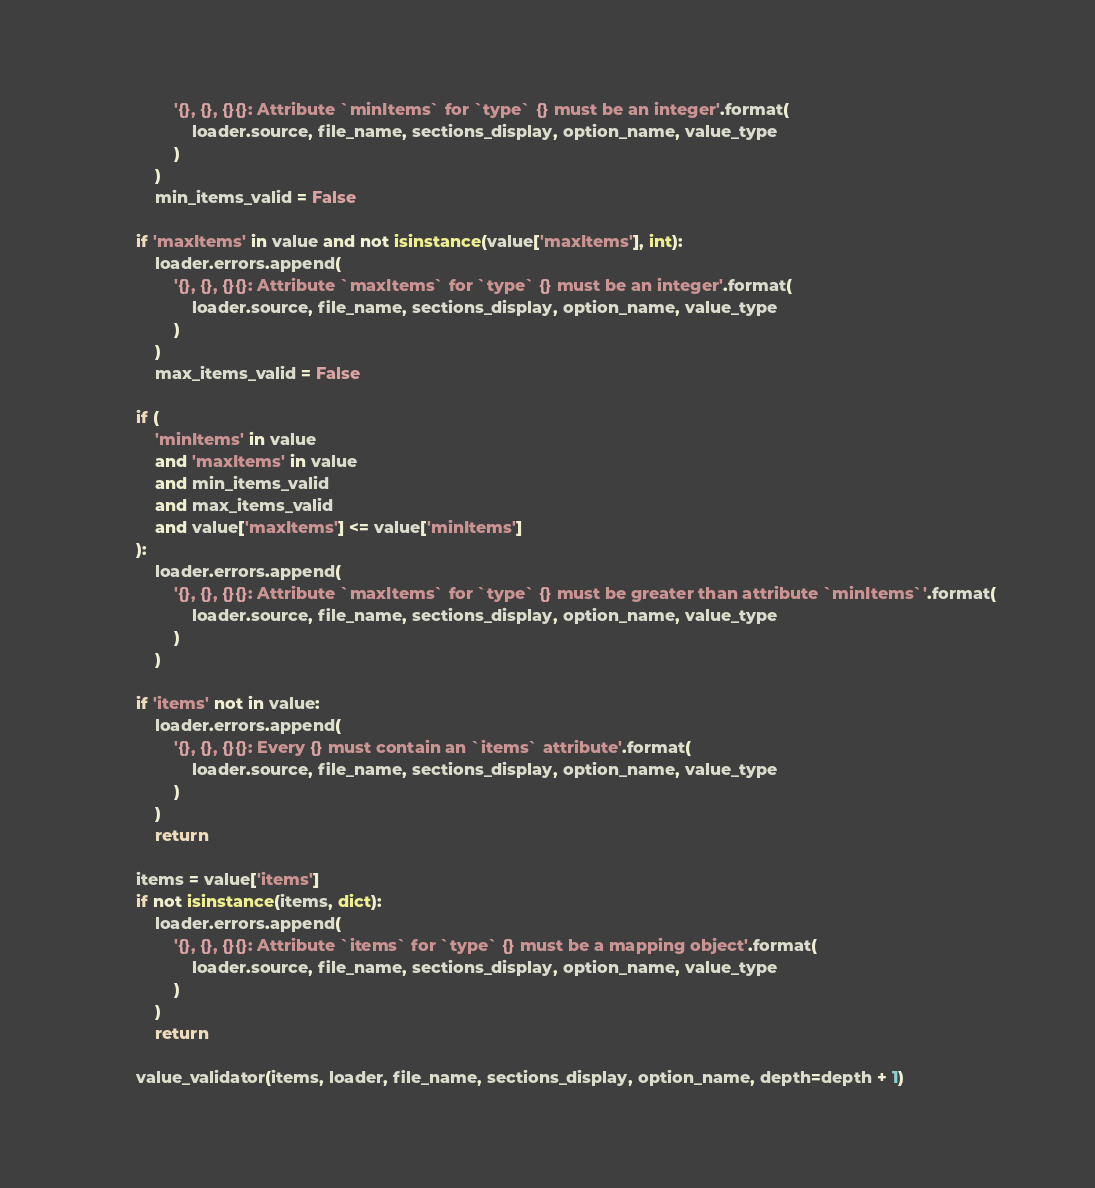Convert code to text. <code><loc_0><loc_0><loc_500><loc_500><_Python_>                '{}, {}, {}{}: Attribute `minItems` for `type` {} must be an integer'.format(
                    loader.source, file_name, sections_display, option_name, value_type
                )
            )
            min_items_valid = False

        if 'maxItems' in value and not isinstance(value['maxItems'], int):
            loader.errors.append(
                '{}, {}, {}{}: Attribute `maxItems` for `type` {} must be an integer'.format(
                    loader.source, file_name, sections_display, option_name, value_type
                )
            )
            max_items_valid = False

        if (
            'minItems' in value
            and 'maxItems' in value
            and min_items_valid
            and max_items_valid
            and value['maxItems'] <= value['minItems']
        ):
            loader.errors.append(
                '{}, {}, {}{}: Attribute `maxItems` for `type` {} must be greater than attribute `minItems`'.format(
                    loader.source, file_name, sections_display, option_name, value_type
                )
            )

        if 'items' not in value:
            loader.errors.append(
                '{}, {}, {}{}: Every {} must contain an `items` attribute'.format(
                    loader.source, file_name, sections_display, option_name, value_type
                )
            )
            return

        items = value['items']
        if not isinstance(items, dict):
            loader.errors.append(
                '{}, {}, {}{}: Attribute `items` for `type` {} must be a mapping object'.format(
                    loader.source, file_name, sections_display, option_name, value_type
                )
            )
            return

        value_validator(items, loader, file_name, sections_display, option_name, depth=depth + 1)</code> 